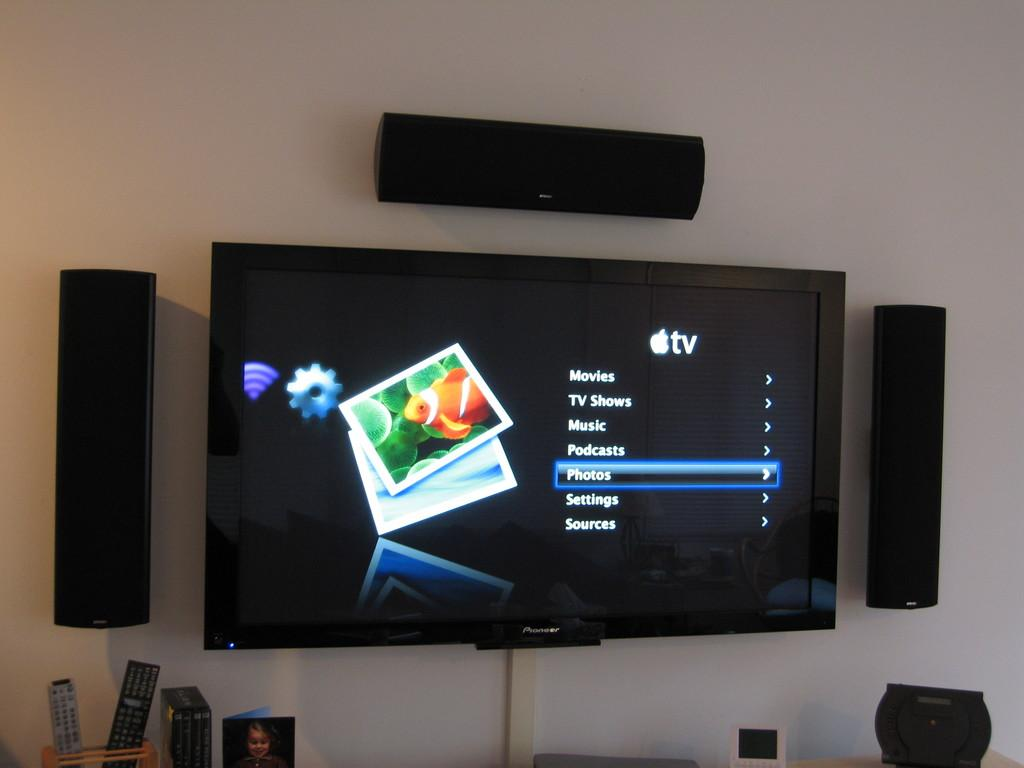<image>
Summarize the visual content of the image. A large, flat screen TV on the wall displays a list of choices for AppleTV, including Movies, TV Shows, and Music.. 